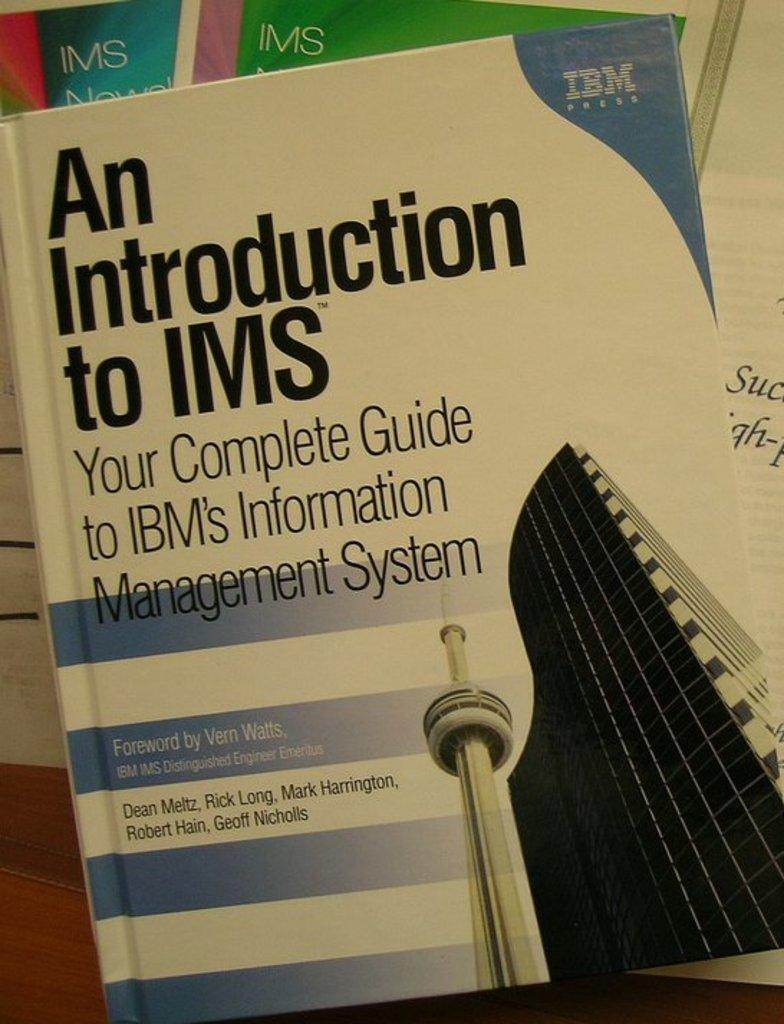<image>
Relay a brief, clear account of the picture shown. The book shown has a foreword by Vern Watts. 